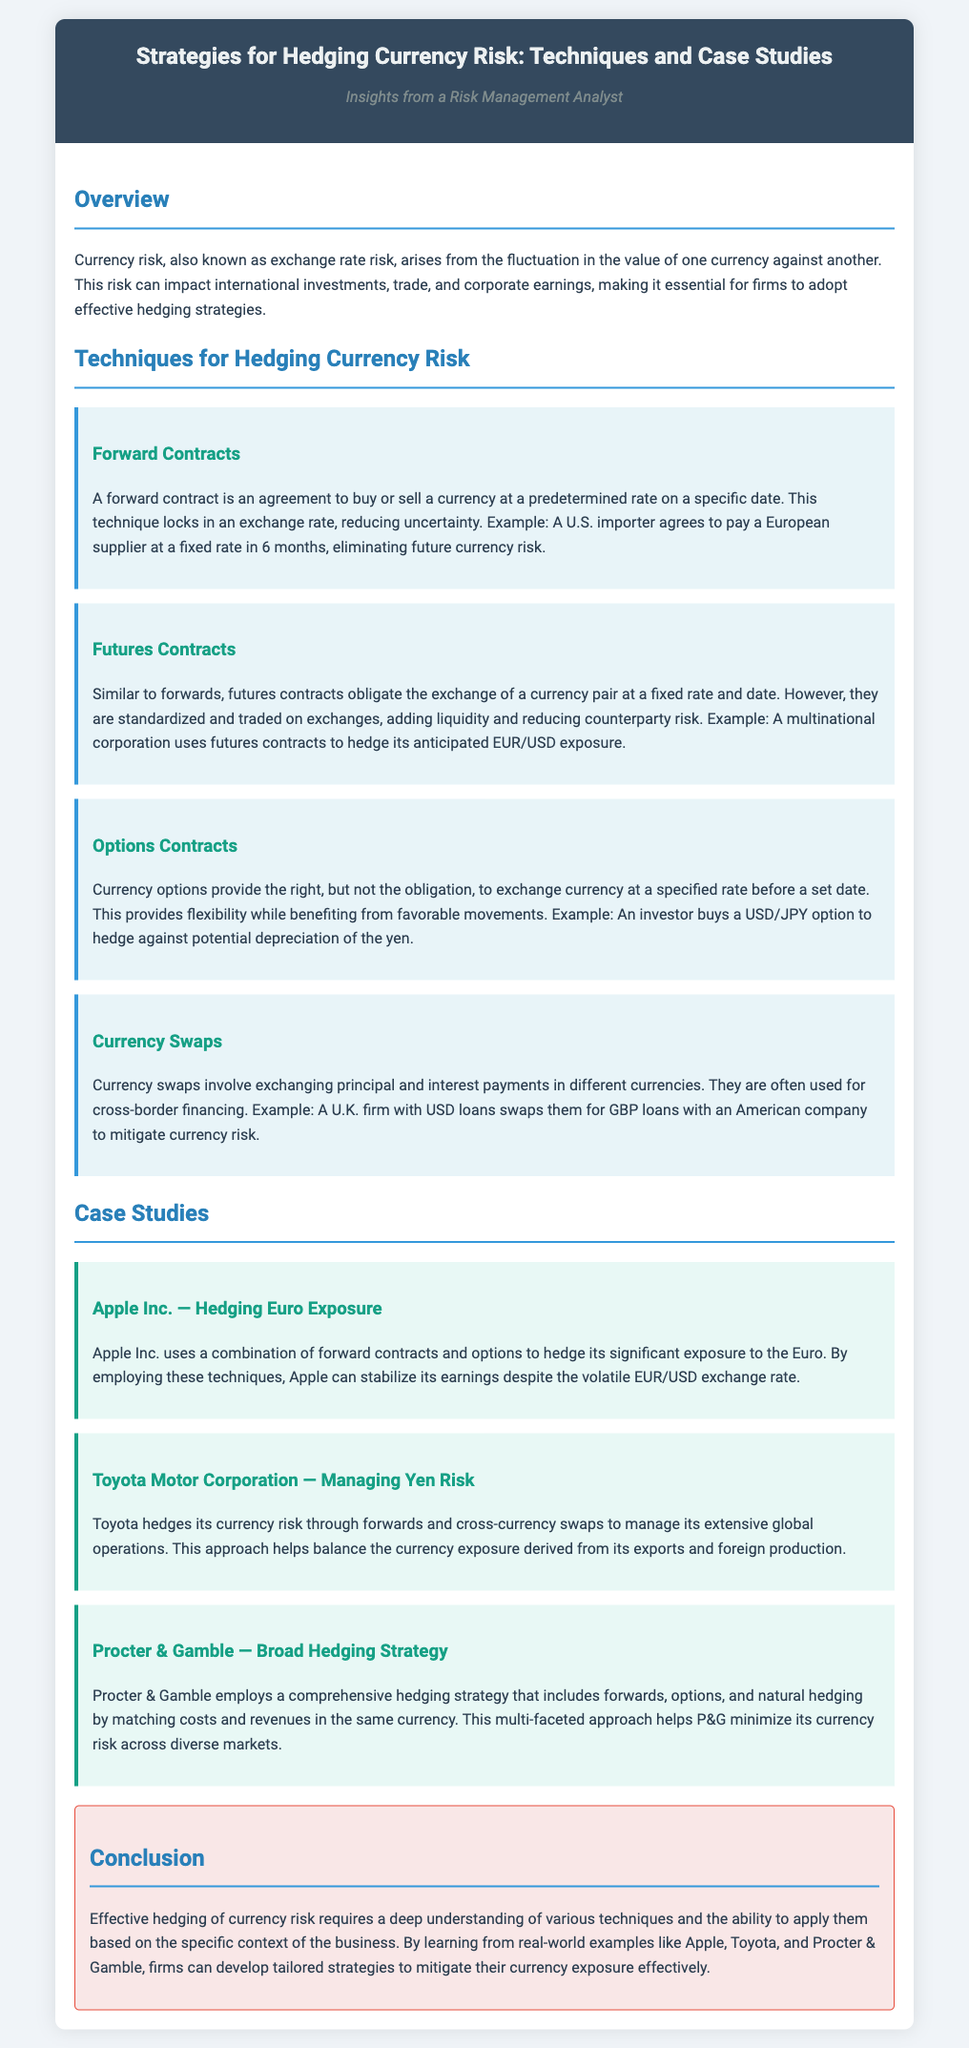What is currency risk? Currency risk is defined as the fluctuation in the value of one currency against another, affecting international investments and trade.
Answer: Fluctuation in currency value What technique uses a predetermined rate on a specific date? The document states that a forward contract is an agreement to buy or sell a currency at a predetermined rate on a specific date.
Answer: Forward Contracts What company uses a combination of forward contracts and options for hedging? The document mentions that Apple Inc. uses a combination of forward contracts and options to hedge its exposure to the Euro.
Answer: Apple Inc Which technique is often used for cross-border financing? Currency swaps are typically employed for cross-border financing according to the document.
Answer: Currency Swaps What is Procter & Gamble's approach to hedging? Procter & Gamble employs a comprehensive hedging strategy that includes forwards, options, and natural hedging.
Answer: Comprehensive hedging strategy What type of document is this? The document presents the strategies for hedging currency risk through techniques and real-world case studies.
Answer: Recipe card How does Toyota manage its currency risk? Toyota hedges its currency risk through forwards and cross-currency swaps according to the case study.
Answer: Forwards and cross-currency swaps What is the primary goal of effective hedging strategies? The document conveys that the primary goal is to mitigate currency exposure effectively.
Answer: Mitigate currency exposure What organization uses futures contracts to hedge its anticipated exposure? The document illustrates that a multinational corporation uses futures contracts for hedging.
Answer: Multinational corporation 